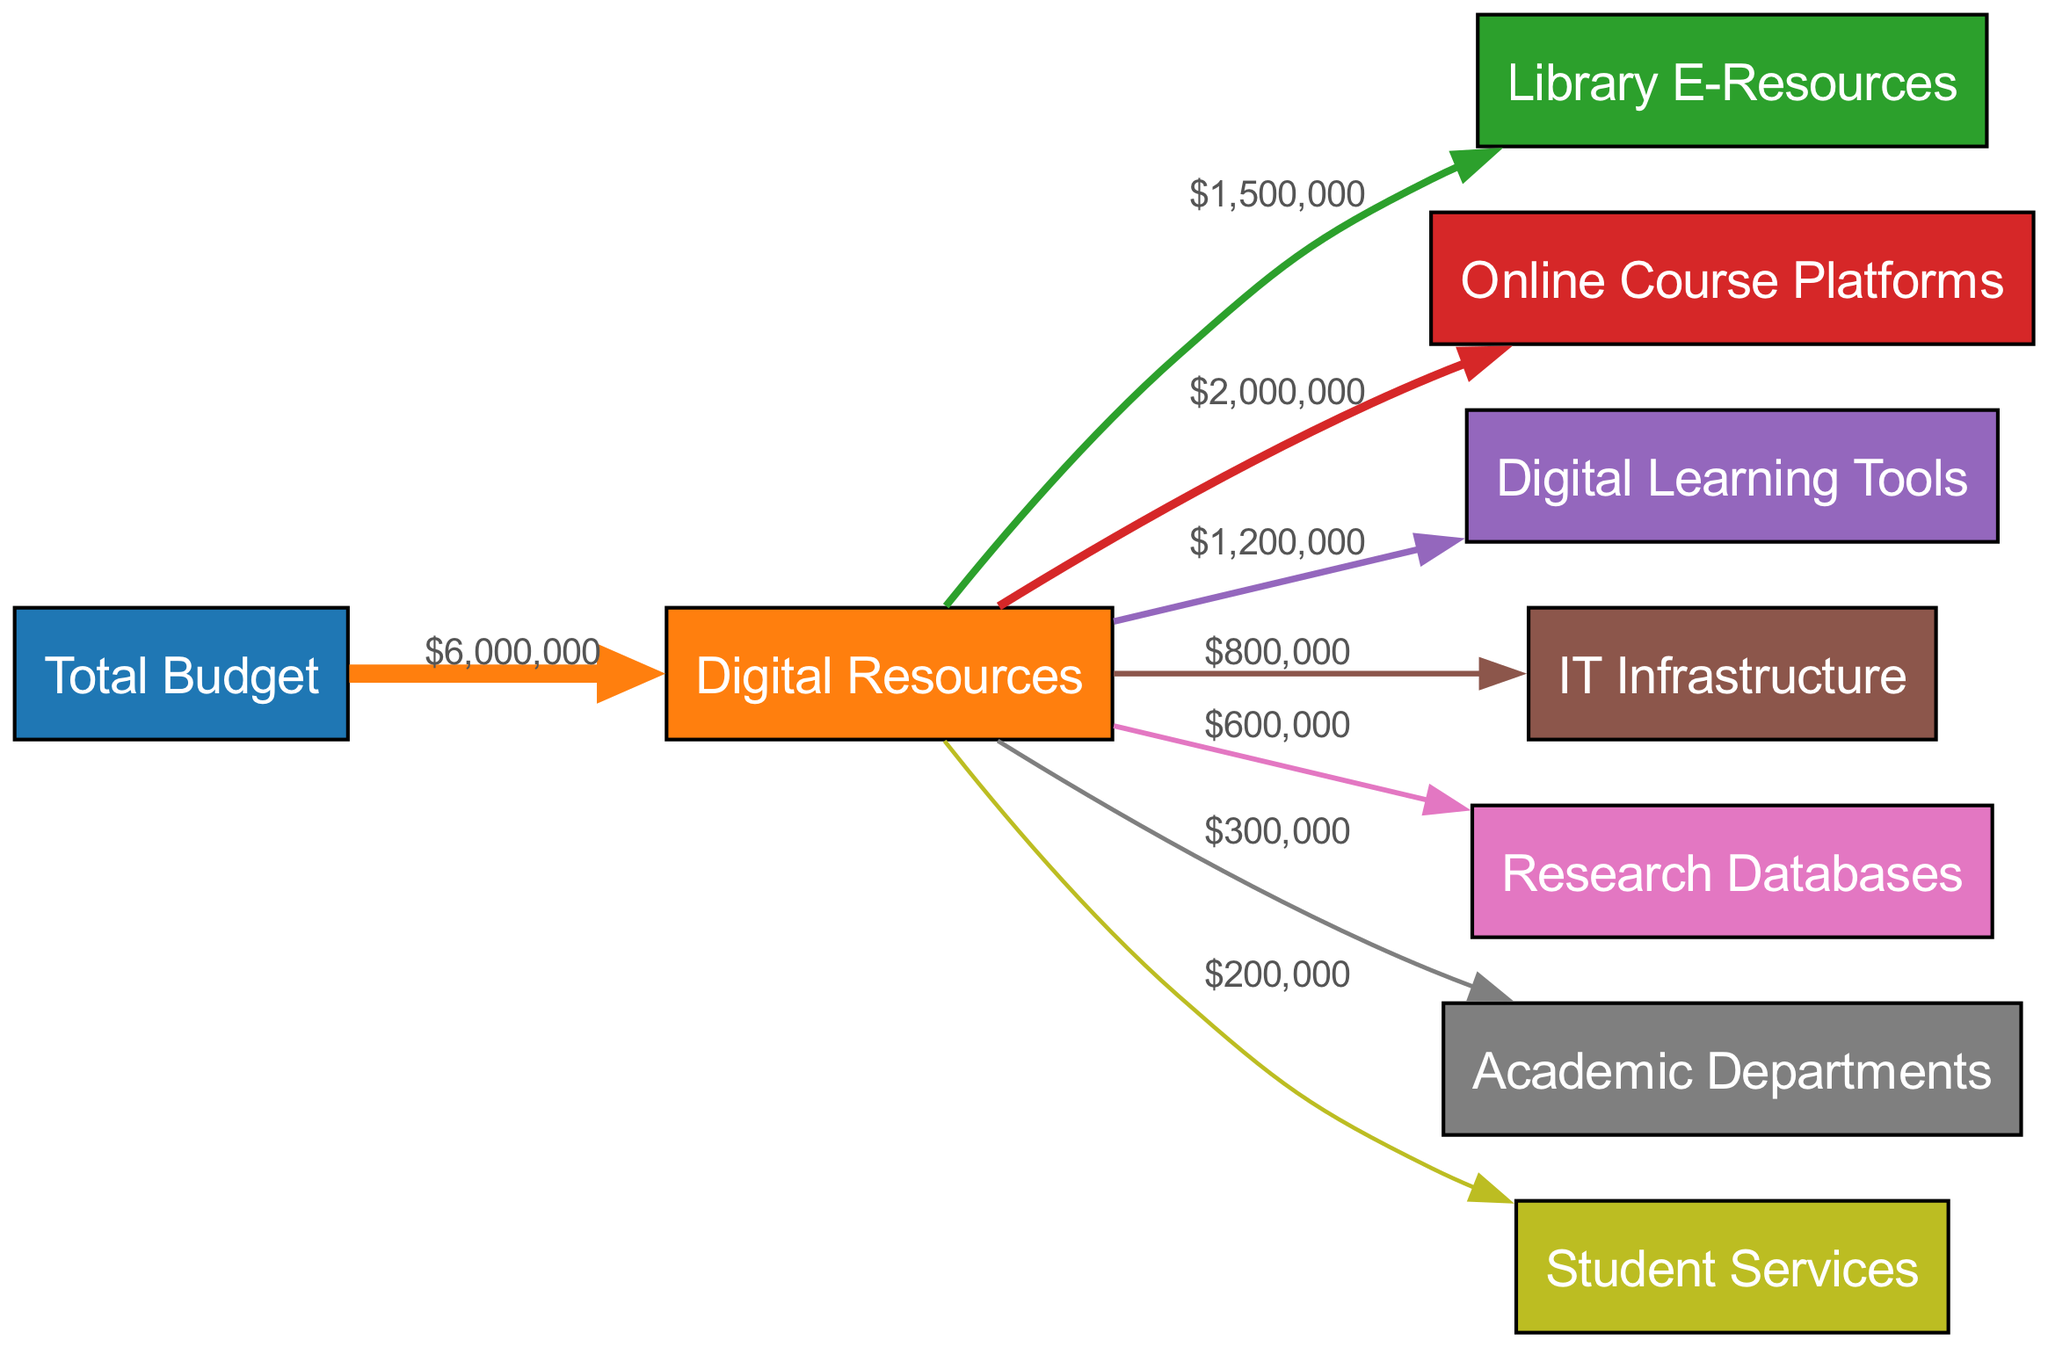What is the total budget allocated for digital resources? The total budget allocated for digital resources is represented by the flow from the "Total Budget" node to the "Digital Resources" node, showing a value of 6,000,000 dollars.
Answer: 6,000,000 Which digital resource receives the highest allocation? By examining the links flowing out from the "Digital Resources" node, the "Online Course Platforms" has the largest value of 2,000,000 dollars, making it the highest allocated digital resource.
Answer: Online Course Platforms How much funding is allocated to IT Infrastructure? The flow from "Digital Resources" to "IT Infrastructure" shows a value of 800,000 dollars, indicating the specific allocation for this item.
Answer: 800,000 What is the combined total for Library E-Resources and Research Databases? To find this, add the values of "Library E-Resources" (1,500,000 dollars) and "Research Databases" (600,000 dollars). This results in a total of 2,100,000 dollars when summed together.
Answer: 2,100,000 How many nodes are there in this diagram? By counting the nodes listed in the "nodes" section of the data, there are a total of 9 nodes reflecting different budget allocations.
Answer: 9 Which department receives the least amount of funding? The least funding goes to "Student Services," with a value of only 200,000 dollars, which is the smallest allocation detailed in the diagram.
Answer: Student Services What is the total amount allocated to Academic Departments and Digital Learning Tools combined? Adding "Academic Departments" (300,000 dollars) and "Digital Learning Tools" (1,200,000 dollars) together gives a combined total of 1,500,000 dollars.
Answer: 1,500,000 How much budget is allocated to online resources compared to traditional resources? All budget flows from "Digital Resources" represent online resources, amounting to 6,000,000 dollars, while traditional physical resources are not indicated in this diagram.
Answer: 6,000,000 What percentage of the digital resources budget is allocated to Library E-Resources? To calculate this, divide the allocation for "Library E-Resources" (1,500,000 dollars) by the total digital resources budget (6,000,000 dollars), resulting in 25 percent as a direct value.
Answer: 25% 